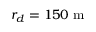Convert formula to latex. <formula><loc_0><loc_0><loc_500><loc_500>r _ { d } = 1 5 0 m</formula> 